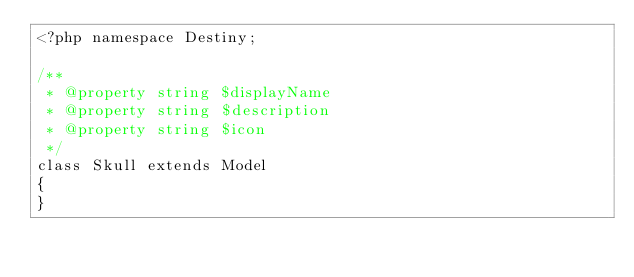<code> <loc_0><loc_0><loc_500><loc_500><_PHP_><?php namespace Destiny;

/**
 * @property string $displayName
 * @property string $description
 * @property string $icon
 */
class Skull extends Model
{
}
</code> 